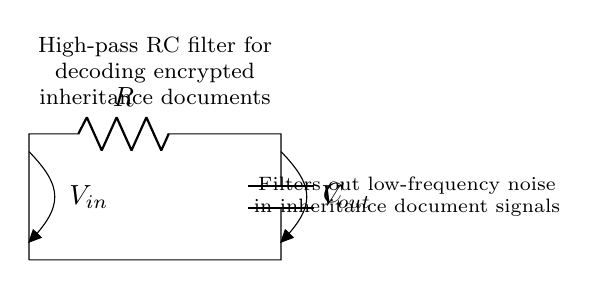What components are present in the circuit? The circuit comprises a resistor and a capacitor, which are connected in a specific arrangement for filtering purposes.
Answer: resistor and capacitor What type of filter is represented by this circuit? The circuit is a high-pass filter, which allows high-frequency signals to pass while attenuating low-frequency signals.
Answer: high-pass filter What does the label Vout represent? The label Vout indicates the output voltage of the circuit, which is measured across the capacitor in this high-pass filter configuration.
Answer: output voltage How does this circuit handle low-frequency signals? The circuit blocks low-frequency signals due to the behavior of the capacitor, which charges and acts as a short circuit at low frequencies.
Answer: blocks What is the function of the resistor in this high-pass filter? The resistor determines the cutoff frequency of the filter and helps in stabilizing the circuit by providing a path for current.
Answer: cutoff frequency Why is this circuit used for decoding encrypted inheritance documents? The high-pass filter effectively removes low-frequency noise from document signals, allowing for clearer signal analysis and decoding.
Answer: removes noise 